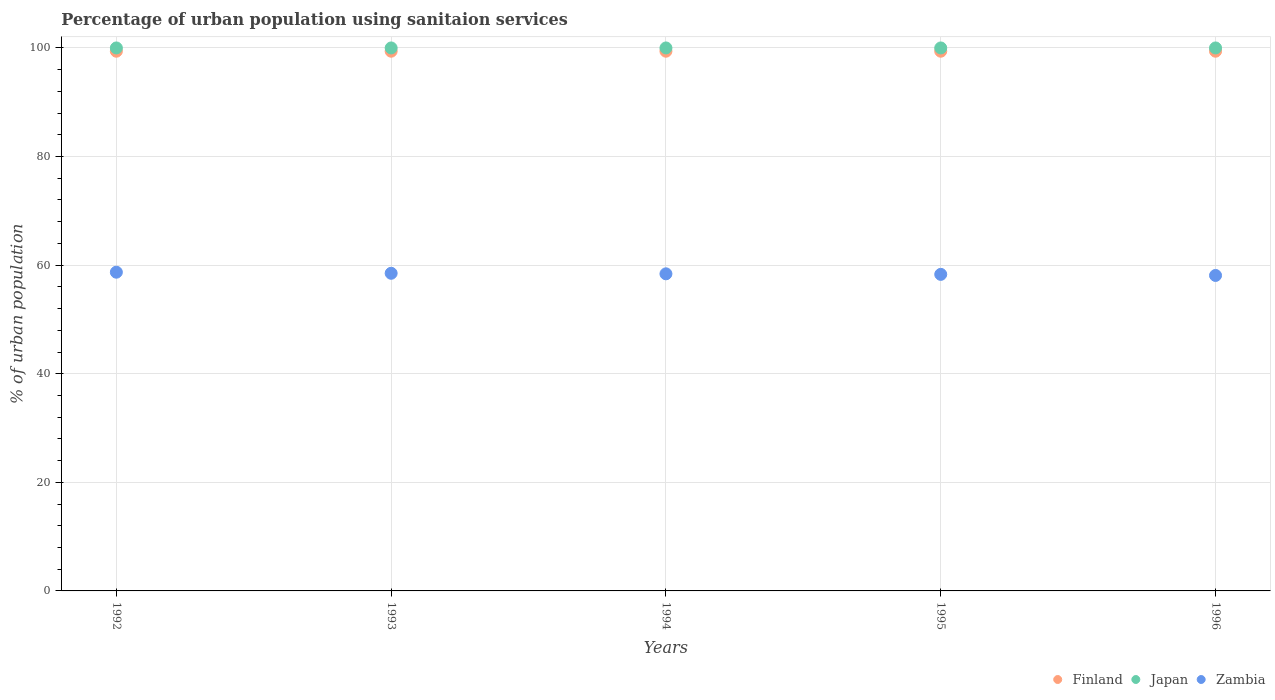How many different coloured dotlines are there?
Your response must be concise. 3. What is the percentage of urban population using sanitaion services in Japan in 1992?
Offer a very short reply. 100. Across all years, what is the maximum percentage of urban population using sanitaion services in Finland?
Your response must be concise. 99.4. Across all years, what is the minimum percentage of urban population using sanitaion services in Finland?
Your response must be concise. 99.4. In which year was the percentage of urban population using sanitaion services in Japan maximum?
Make the answer very short. 1992. In which year was the percentage of urban population using sanitaion services in Finland minimum?
Provide a succinct answer. 1992. What is the total percentage of urban population using sanitaion services in Finland in the graph?
Your response must be concise. 497. What is the difference between the percentage of urban population using sanitaion services in Zambia in 1992 and that in 1996?
Provide a succinct answer. 0.6. What is the difference between the percentage of urban population using sanitaion services in Finland in 1993 and the percentage of urban population using sanitaion services in Japan in 1996?
Offer a very short reply. -0.6. What is the average percentage of urban population using sanitaion services in Finland per year?
Give a very brief answer. 99.4. In the year 1995, what is the difference between the percentage of urban population using sanitaion services in Finland and percentage of urban population using sanitaion services in Zambia?
Provide a succinct answer. 41.1. What is the ratio of the percentage of urban population using sanitaion services in Zambia in 1993 to that in 1995?
Give a very brief answer. 1. Is the difference between the percentage of urban population using sanitaion services in Finland in 1992 and 1996 greater than the difference between the percentage of urban population using sanitaion services in Zambia in 1992 and 1996?
Offer a very short reply. No. What is the difference between the highest and the second highest percentage of urban population using sanitaion services in Zambia?
Give a very brief answer. 0.2. What is the difference between the highest and the lowest percentage of urban population using sanitaion services in Zambia?
Your answer should be very brief. 0.6. In how many years, is the percentage of urban population using sanitaion services in Zambia greater than the average percentage of urban population using sanitaion services in Zambia taken over all years?
Offer a terse response. 2. Is the sum of the percentage of urban population using sanitaion services in Zambia in 1994 and 1996 greater than the maximum percentage of urban population using sanitaion services in Finland across all years?
Your response must be concise. Yes. Is it the case that in every year, the sum of the percentage of urban population using sanitaion services in Zambia and percentage of urban population using sanitaion services in Finland  is greater than the percentage of urban population using sanitaion services in Japan?
Offer a terse response. Yes. Is the percentage of urban population using sanitaion services in Japan strictly greater than the percentage of urban population using sanitaion services in Zambia over the years?
Provide a succinct answer. Yes. Is the percentage of urban population using sanitaion services in Zambia strictly less than the percentage of urban population using sanitaion services in Japan over the years?
Your response must be concise. Yes. Does the graph contain any zero values?
Offer a very short reply. No. Where does the legend appear in the graph?
Provide a short and direct response. Bottom right. How are the legend labels stacked?
Provide a succinct answer. Horizontal. What is the title of the graph?
Your answer should be compact. Percentage of urban population using sanitaion services. Does "Aruba" appear as one of the legend labels in the graph?
Offer a terse response. No. What is the label or title of the Y-axis?
Provide a succinct answer. % of urban population. What is the % of urban population in Finland in 1992?
Your response must be concise. 99.4. What is the % of urban population of Zambia in 1992?
Your answer should be very brief. 58.7. What is the % of urban population in Finland in 1993?
Keep it short and to the point. 99.4. What is the % of urban population in Japan in 1993?
Offer a terse response. 100. What is the % of urban population in Zambia in 1993?
Your answer should be very brief. 58.5. What is the % of urban population in Finland in 1994?
Offer a very short reply. 99.4. What is the % of urban population in Zambia in 1994?
Offer a terse response. 58.4. What is the % of urban population of Finland in 1995?
Make the answer very short. 99.4. What is the % of urban population in Japan in 1995?
Ensure brevity in your answer.  100. What is the % of urban population of Zambia in 1995?
Your answer should be very brief. 58.3. What is the % of urban population in Finland in 1996?
Provide a succinct answer. 99.4. What is the % of urban population in Japan in 1996?
Keep it short and to the point. 100. What is the % of urban population of Zambia in 1996?
Your response must be concise. 58.1. Across all years, what is the maximum % of urban population of Finland?
Offer a terse response. 99.4. Across all years, what is the maximum % of urban population of Zambia?
Your answer should be very brief. 58.7. Across all years, what is the minimum % of urban population of Finland?
Ensure brevity in your answer.  99.4. Across all years, what is the minimum % of urban population in Zambia?
Your response must be concise. 58.1. What is the total % of urban population of Finland in the graph?
Offer a very short reply. 497. What is the total % of urban population in Zambia in the graph?
Offer a very short reply. 292. What is the difference between the % of urban population of Finland in 1992 and that in 1993?
Your answer should be very brief. 0. What is the difference between the % of urban population of Japan in 1992 and that in 1993?
Ensure brevity in your answer.  0. What is the difference between the % of urban population in Finland in 1992 and that in 1994?
Give a very brief answer. 0. What is the difference between the % of urban population in Japan in 1992 and that in 1994?
Provide a succinct answer. 0. What is the difference between the % of urban population of Zambia in 1992 and that in 1994?
Make the answer very short. 0.3. What is the difference between the % of urban population in Zambia in 1992 and that in 1995?
Provide a succinct answer. 0.4. What is the difference between the % of urban population in Japan in 1992 and that in 1996?
Your answer should be compact. 0. What is the difference between the % of urban population of Finland in 1993 and that in 1994?
Your answer should be very brief. 0. What is the difference between the % of urban population in Zambia in 1993 and that in 1994?
Your answer should be very brief. 0.1. What is the difference between the % of urban population of Finland in 1993 and that in 1995?
Keep it short and to the point. 0. What is the difference between the % of urban population in Japan in 1993 and that in 1995?
Ensure brevity in your answer.  0. What is the difference between the % of urban population of Zambia in 1993 and that in 1995?
Provide a succinct answer. 0.2. What is the difference between the % of urban population of Finland in 1993 and that in 1996?
Provide a succinct answer. 0. What is the difference between the % of urban population in Japan in 1993 and that in 1996?
Offer a very short reply. 0. What is the difference between the % of urban population of Japan in 1994 and that in 1995?
Ensure brevity in your answer.  0. What is the difference between the % of urban population in Zambia in 1994 and that in 1995?
Provide a succinct answer. 0.1. What is the difference between the % of urban population in Finland in 1994 and that in 1996?
Your answer should be compact. 0. What is the difference between the % of urban population of Finland in 1995 and that in 1996?
Ensure brevity in your answer.  0. What is the difference between the % of urban population in Japan in 1995 and that in 1996?
Give a very brief answer. 0. What is the difference between the % of urban population of Zambia in 1995 and that in 1996?
Offer a terse response. 0.2. What is the difference between the % of urban population of Finland in 1992 and the % of urban population of Zambia in 1993?
Your answer should be compact. 40.9. What is the difference between the % of urban population of Japan in 1992 and the % of urban population of Zambia in 1993?
Your response must be concise. 41.5. What is the difference between the % of urban population of Finland in 1992 and the % of urban population of Zambia in 1994?
Provide a short and direct response. 41. What is the difference between the % of urban population of Japan in 1992 and the % of urban population of Zambia in 1994?
Provide a succinct answer. 41.6. What is the difference between the % of urban population in Finland in 1992 and the % of urban population in Zambia in 1995?
Provide a succinct answer. 41.1. What is the difference between the % of urban population in Japan in 1992 and the % of urban population in Zambia in 1995?
Your response must be concise. 41.7. What is the difference between the % of urban population in Finland in 1992 and the % of urban population in Japan in 1996?
Give a very brief answer. -0.6. What is the difference between the % of urban population of Finland in 1992 and the % of urban population of Zambia in 1996?
Keep it short and to the point. 41.3. What is the difference between the % of urban population in Japan in 1992 and the % of urban population in Zambia in 1996?
Provide a succinct answer. 41.9. What is the difference between the % of urban population in Finland in 1993 and the % of urban population in Japan in 1994?
Ensure brevity in your answer.  -0.6. What is the difference between the % of urban population in Japan in 1993 and the % of urban population in Zambia in 1994?
Keep it short and to the point. 41.6. What is the difference between the % of urban population of Finland in 1993 and the % of urban population of Zambia in 1995?
Your response must be concise. 41.1. What is the difference between the % of urban population of Japan in 1993 and the % of urban population of Zambia in 1995?
Your answer should be very brief. 41.7. What is the difference between the % of urban population of Finland in 1993 and the % of urban population of Zambia in 1996?
Ensure brevity in your answer.  41.3. What is the difference between the % of urban population in Japan in 1993 and the % of urban population in Zambia in 1996?
Provide a short and direct response. 41.9. What is the difference between the % of urban population of Finland in 1994 and the % of urban population of Japan in 1995?
Your answer should be very brief. -0.6. What is the difference between the % of urban population of Finland in 1994 and the % of urban population of Zambia in 1995?
Provide a succinct answer. 41.1. What is the difference between the % of urban population of Japan in 1994 and the % of urban population of Zambia in 1995?
Offer a terse response. 41.7. What is the difference between the % of urban population of Finland in 1994 and the % of urban population of Zambia in 1996?
Keep it short and to the point. 41.3. What is the difference between the % of urban population of Japan in 1994 and the % of urban population of Zambia in 1996?
Offer a very short reply. 41.9. What is the difference between the % of urban population of Finland in 1995 and the % of urban population of Zambia in 1996?
Give a very brief answer. 41.3. What is the difference between the % of urban population in Japan in 1995 and the % of urban population in Zambia in 1996?
Your response must be concise. 41.9. What is the average % of urban population in Finland per year?
Your response must be concise. 99.4. What is the average % of urban population of Zambia per year?
Keep it short and to the point. 58.4. In the year 1992, what is the difference between the % of urban population of Finland and % of urban population of Zambia?
Your response must be concise. 40.7. In the year 1992, what is the difference between the % of urban population of Japan and % of urban population of Zambia?
Keep it short and to the point. 41.3. In the year 1993, what is the difference between the % of urban population in Finland and % of urban population in Japan?
Your answer should be very brief. -0.6. In the year 1993, what is the difference between the % of urban population in Finland and % of urban population in Zambia?
Provide a succinct answer. 40.9. In the year 1993, what is the difference between the % of urban population of Japan and % of urban population of Zambia?
Provide a short and direct response. 41.5. In the year 1994, what is the difference between the % of urban population in Finland and % of urban population in Japan?
Make the answer very short. -0.6. In the year 1994, what is the difference between the % of urban population in Finland and % of urban population in Zambia?
Offer a terse response. 41. In the year 1994, what is the difference between the % of urban population of Japan and % of urban population of Zambia?
Offer a terse response. 41.6. In the year 1995, what is the difference between the % of urban population of Finland and % of urban population of Japan?
Keep it short and to the point. -0.6. In the year 1995, what is the difference between the % of urban population of Finland and % of urban population of Zambia?
Offer a very short reply. 41.1. In the year 1995, what is the difference between the % of urban population of Japan and % of urban population of Zambia?
Ensure brevity in your answer.  41.7. In the year 1996, what is the difference between the % of urban population of Finland and % of urban population of Japan?
Your answer should be very brief. -0.6. In the year 1996, what is the difference between the % of urban population in Finland and % of urban population in Zambia?
Give a very brief answer. 41.3. In the year 1996, what is the difference between the % of urban population in Japan and % of urban population in Zambia?
Keep it short and to the point. 41.9. What is the ratio of the % of urban population of Japan in 1992 to that in 1993?
Provide a short and direct response. 1. What is the ratio of the % of urban population of Finland in 1992 to that in 1995?
Your answer should be very brief. 1. What is the ratio of the % of urban population in Finland in 1992 to that in 1996?
Your response must be concise. 1. What is the ratio of the % of urban population in Zambia in 1992 to that in 1996?
Offer a very short reply. 1.01. What is the ratio of the % of urban population in Japan in 1993 to that in 1994?
Keep it short and to the point. 1. What is the ratio of the % of urban population of Finland in 1993 to that in 1995?
Provide a short and direct response. 1. What is the ratio of the % of urban population in Finland in 1993 to that in 1996?
Ensure brevity in your answer.  1. What is the ratio of the % of urban population in Finland in 1994 to that in 1995?
Your response must be concise. 1. What is the ratio of the % of urban population in Japan in 1994 to that in 1995?
Offer a terse response. 1. What is the ratio of the % of urban population in Zambia in 1994 to that in 1995?
Ensure brevity in your answer.  1. What is the ratio of the % of urban population in Finland in 1994 to that in 1996?
Offer a very short reply. 1. What is the ratio of the % of urban population in Japan in 1994 to that in 1996?
Your response must be concise. 1. What is the ratio of the % of urban population of Zambia in 1994 to that in 1996?
Provide a succinct answer. 1.01. What is the ratio of the % of urban population in Zambia in 1995 to that in 1996?
Offer a terse response. 1. What is the difference between the highest and the second highest % of urban population of Finland?
Provide a succinct answer. 0. What is the difference between the highest and the second highest % of urban population in Zambia?
Provide a succinct answer. 0.2. What is the difference between the highest and the lowest % of urban population in Japan?
Provide a short and direct response. 0. 